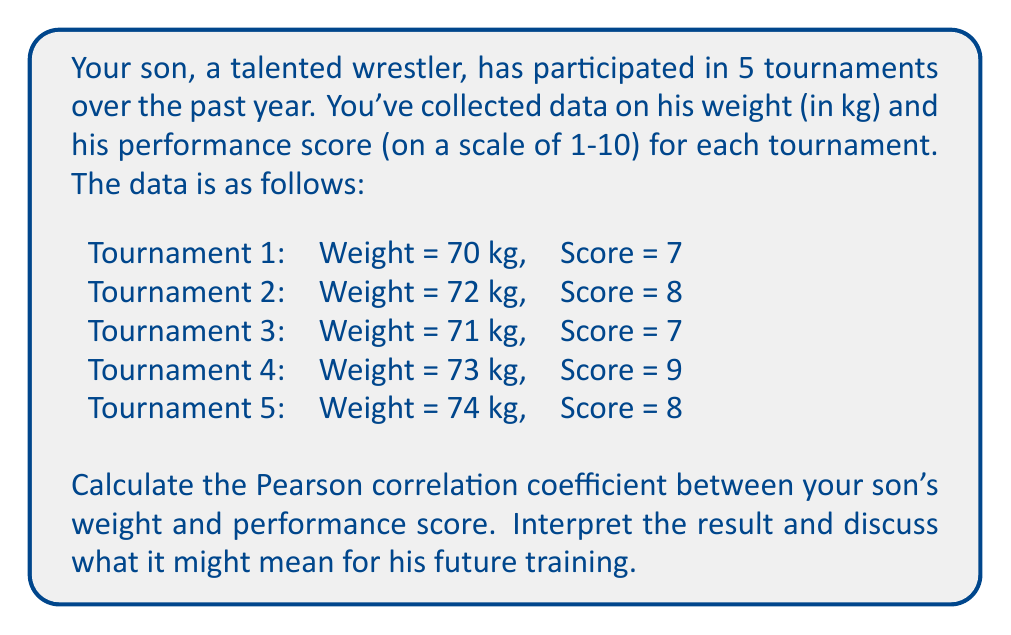Teach me how to tackle this problem. To calculate the Pearson correlation coefficient between weight and performance score, we'll follow these steps:

1. Calculate the means of weight ($\bar{x}$) and score ($\bar{y}$):

   $\bar{x} = \frac{70 + 72 + 71 + 73 + 74}{5} = 72$ kg
   $\bar{y} = \frac{7 + 8 + 7 + 9 + 8}{5} = 7.8$

2. Calculate the deviations from the mean for both variables:

   Weight deviations: -2, 0, -1, 1, 2
   Score deviations: -0.8, 0.2, -0.8, 1.2, 0.2

3. Calculate the products of the deviations:

   1.6, 0, 0.8, 1.2, 0.4

4. Sum the products of deviations:

   $\sum(x_i - \bar{x})(y_i - \bar{y}) = 1.6 + 0 + 0.8 + 1.2 + 0.4 = 4$

5. Calculate the sum of squared deviations for each variable:

   $\sum(x_i - \bar{x})^2 = 4 + 0 + 1 + 1 + 4 = 10$
   $\sum(y_i - \bar{y})^2 = 0.64 + 0.04 + 0.64 + 1.44 + 0.04 = 2.8$

6. Apply the Pearson correlation coefficient formula:

   $$r = \frac{\sum(x_i - \bar{x})(y_i - \bar{y})}{\sqrt{\sum(x_i - \bar{x})^2 \sum(y_i - \bar{y})^2}}$$

   $$r = \frac{4}{\sqrt{10 \times 2.8}} = \frac{4}{\sqrt{28}} = \frac{4}{5.29} \approx 0.756$$

The Pearson correlation coefficient is approximately 0.756, which indicates a strong positive correlation between your son's weight and performance score.

Interpretation: This result suggests that as your son's weight increased, his performance scores tended to improve. The correlation is strong (close to 1), but not perfect. This could mean that gaining weight (likely muscle mass) has been beneficial for his wrestling performance.

For future training, this information might suggest:
1. Controlled weight gain could potentially lead to improved performance.
2. Strength training to build muscle mass might be beneficial.
3. However, it's important to maintain a balance, as excessive weight gain might not always translate to better performance.
4. Other factors (technique, strategy, mental preparation) also play crucial roles in performance and should not be neglected.
Answer: The Pearson correlation coefficient between your son's weight and performance score is approximately 0.756, indicating a strong positive correlation. 